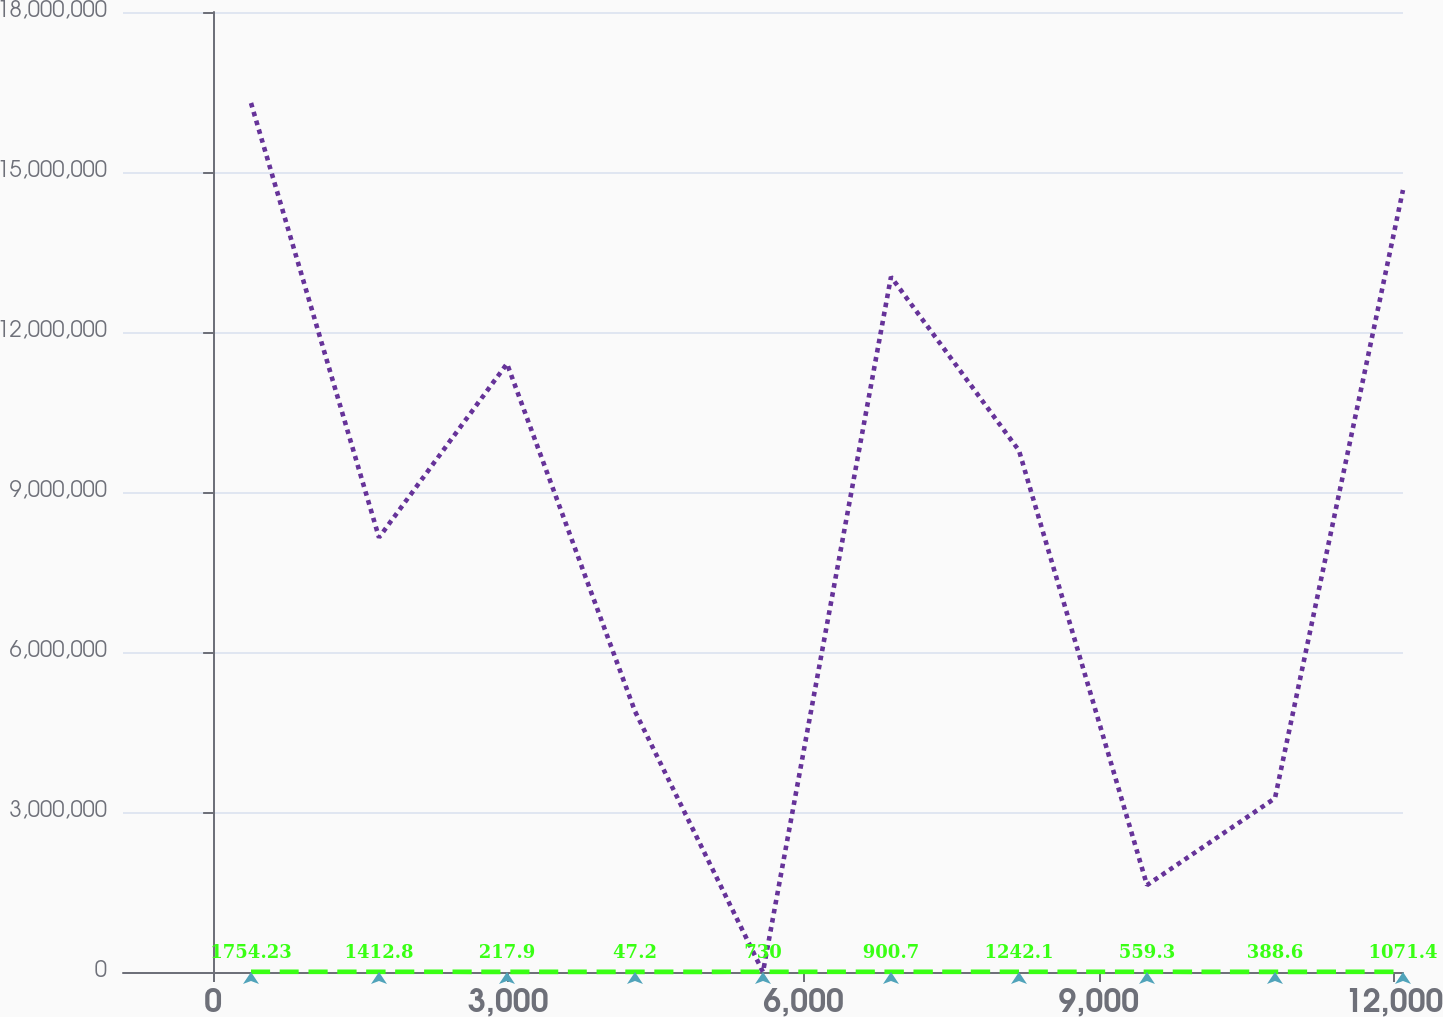Convert chart. <chart><loc_0><loc_0><loc_500><loc_500><line_chart><ecel><fcel>Unnamed: 1<fcel>Year-over-Year Change<nl><fcel>384.96<fcel>1754.23<fcel>1.62937e+07<nl><fcel>1685.46<fcel>1412.8<fcel>8.14686e+06<nl><fcel>2985.96<fcel>217.9<fcel>1.14056e+07<nl><fcel>4286.46<fcel>47.2<fcel>4.88811e+06<nl><fcel>5586.96<fcel>730<fcel>0.89<nl><fcel>6887.46<fcel>900.7<fcel>1.3035e+07<nl><fcel>8187.96<fcel>1242.1<fcel>9.77623e+06<nl><fcel>9488.46<fcel>559.3<fcel>1.62937e+06<nl><fcel>10789<fcel>388.6<fcel>3.25874e+06<nl><fcel>12089.5<fcel>1071.4<fcel>1.46643e+07<nl><fcel>13390<fcel>1583.5<fcel>6.51748e+06<nl></chart> 